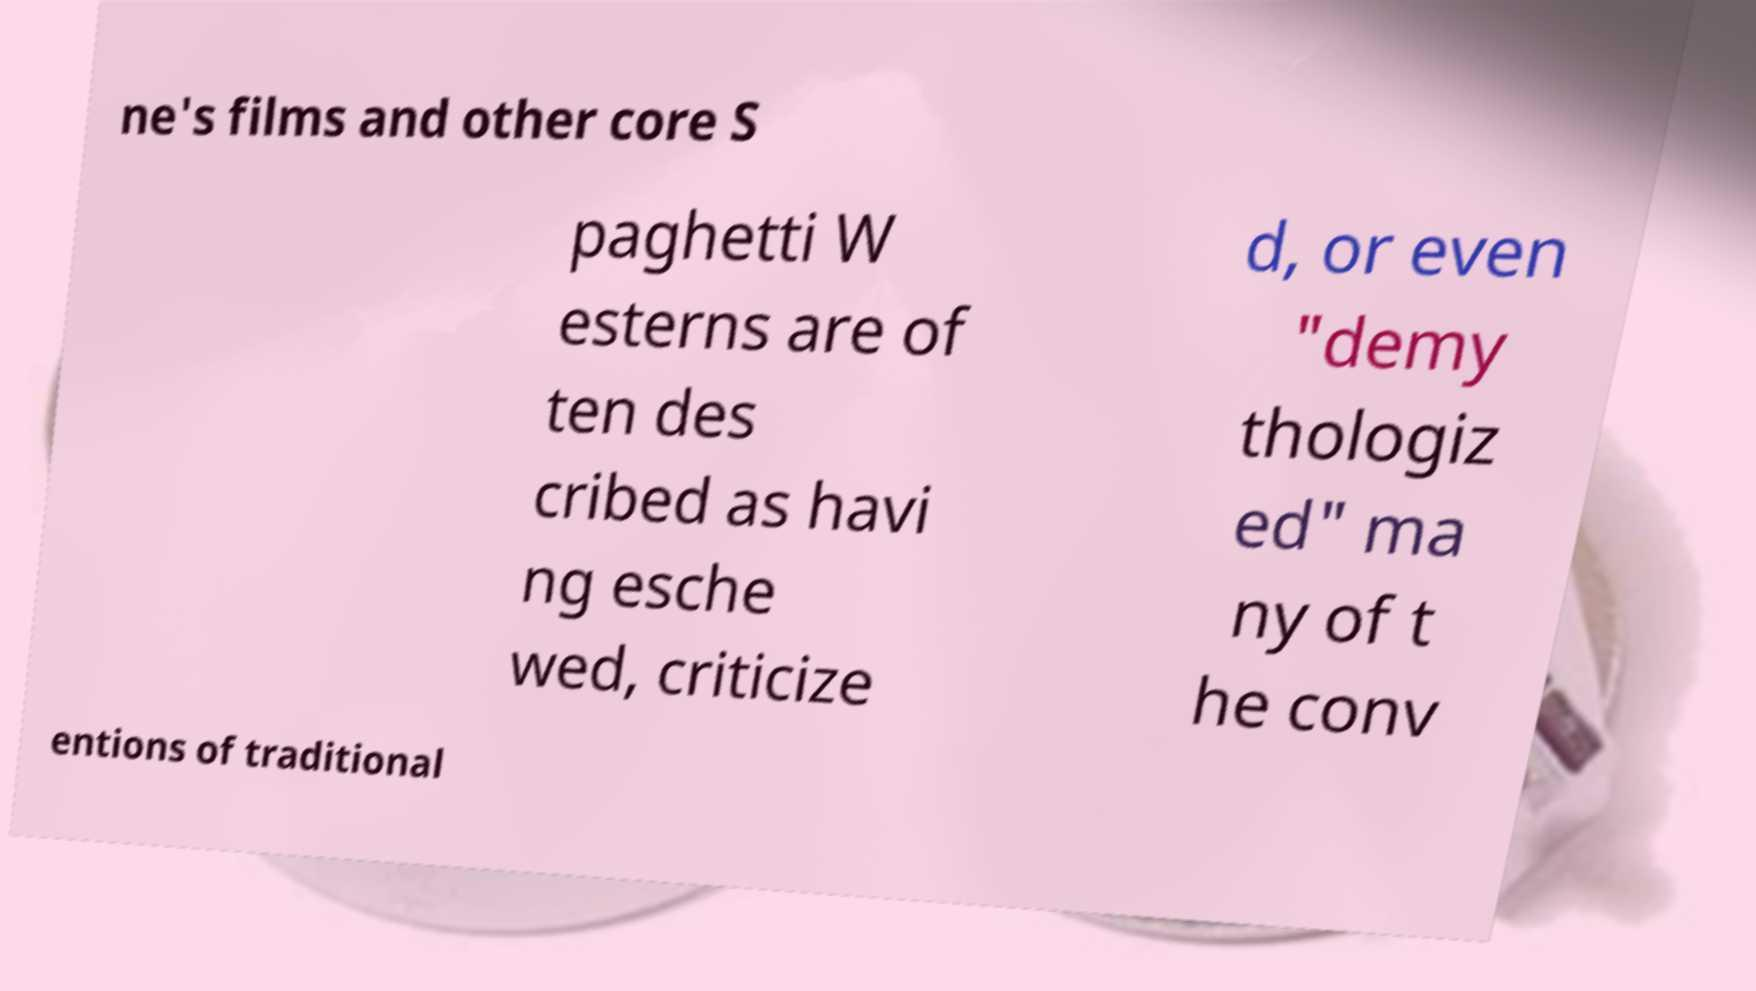Could you extract and type out the text from this image? ne's films and other core S paghetti W esterns are of ten des cribed as havi ng esche wed, criticize d, or even "demy thologiz ed" ma ny of t he conv entions of traditional 